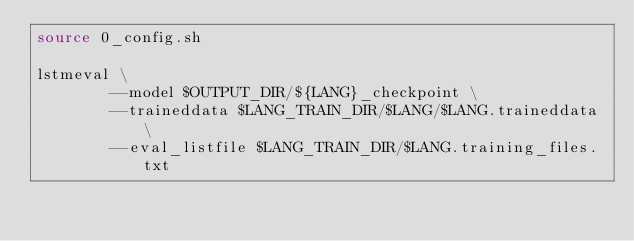Convert code to text. <code><loc_0><loc_0><loc_500><loc_500><_Bash_>source 0_config.sh

lstmeval \
        --model $OUTPUT_DIR/${LANG}_checkpoint \
        --traineddata $LANG_TRAIN_DIR/$LANG/$LANG.traineddata \
        --eval_listfile $LANG_TRAIN_DIR/$LANG.training_files.txt

</code> 